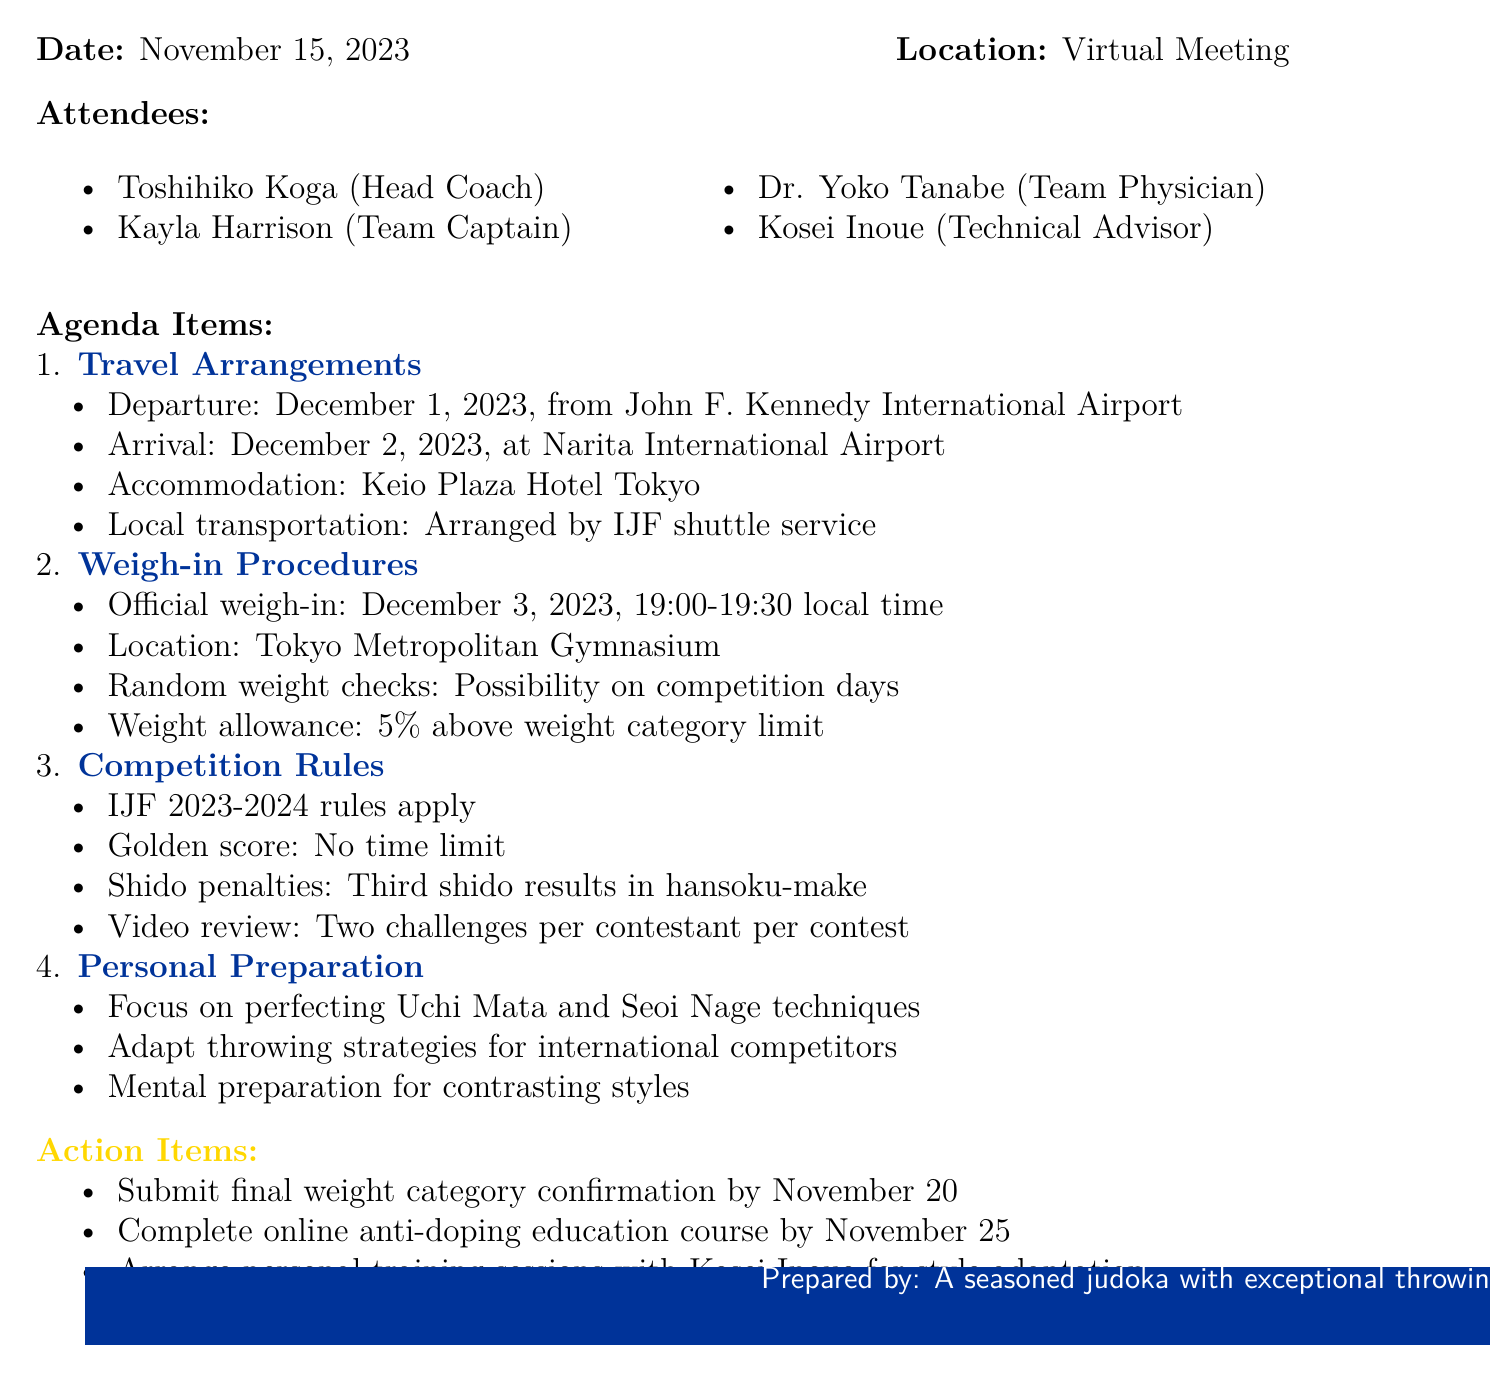What is the title of the meeting? The title of the meeting is the main subject stated at the beginning of the document.
Answer: International Judo Federation Grand Slam Tokyo 2023 Preparation What is the date of the official weigh-in? The date is specified under the weigh-in procedures section.
Answer: December 3, 2023 Where will the team be staying in Tokyo? The accommodation details are provided in the travel arrangements section.
Answer: Keio Plaza Hotel Tokyo What is the local time for the official weigh-in? The time is stated alongside the date in the weigh-in procedures.
Answer: 19:00-19:30 How many challenges does a contestant have for video review? The number of challenges is mentioned under the competition rules.
Answer: Two challenges What is the departure airport for the tournament? The departure airport is mentioned in the travel arrangements section.
Answer: John F. Kennedy International Airport How many attendees were present at the meeting? The number of attendees can be counted from the list in the document.
Answer: Four attendees What is the weight allowance for competitors? The weight allowance is specified in the weigh-in procedures section.
Answer: 5% above weight category limit What is one of the personal preparation focuses mentioned? The focus areas are listed in the personal preparation agenda item.
Answer: Perfecting Uchi Mata and Seoi Nage techniques 